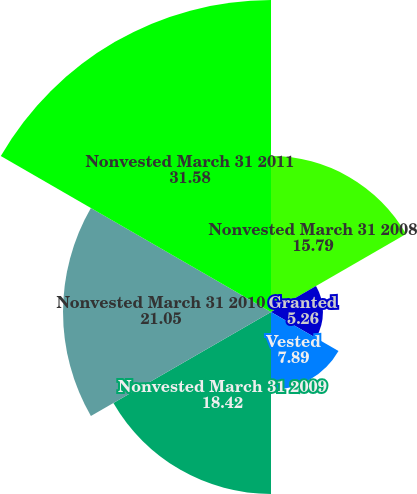Convert chart. <chart><loc_0><loc_0><loc_500><loc_500><pie_chart><fcel>Nonvested March 31 2008<fcel>Granted<fcel>Vested<fcel>Nonvested March 31 2009<fcel>Nonvested March 31 2010<fcel>Nonvested March 31 2011<nl><fcel>15.79%<fcel>5.26%<fcel>7.89%<fcel>18.42%<fcel>21.05%<fcel>31.58%<nl></chart> 